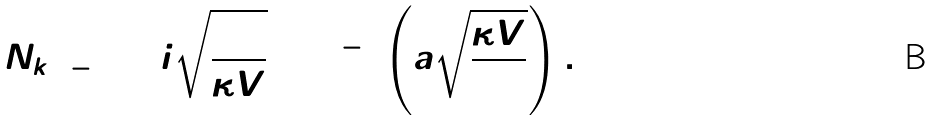<formula> <loc_0><loc_0><loc_500><loc_500>N _ { k = - 1 } = i \sqrt { \frac { 3 } { \kappa V } } \sinh ^ { - 1 } \left ( \bar { a } \sqrt { \frac { \kappa V } { 3 } } \right ) .</formula> 